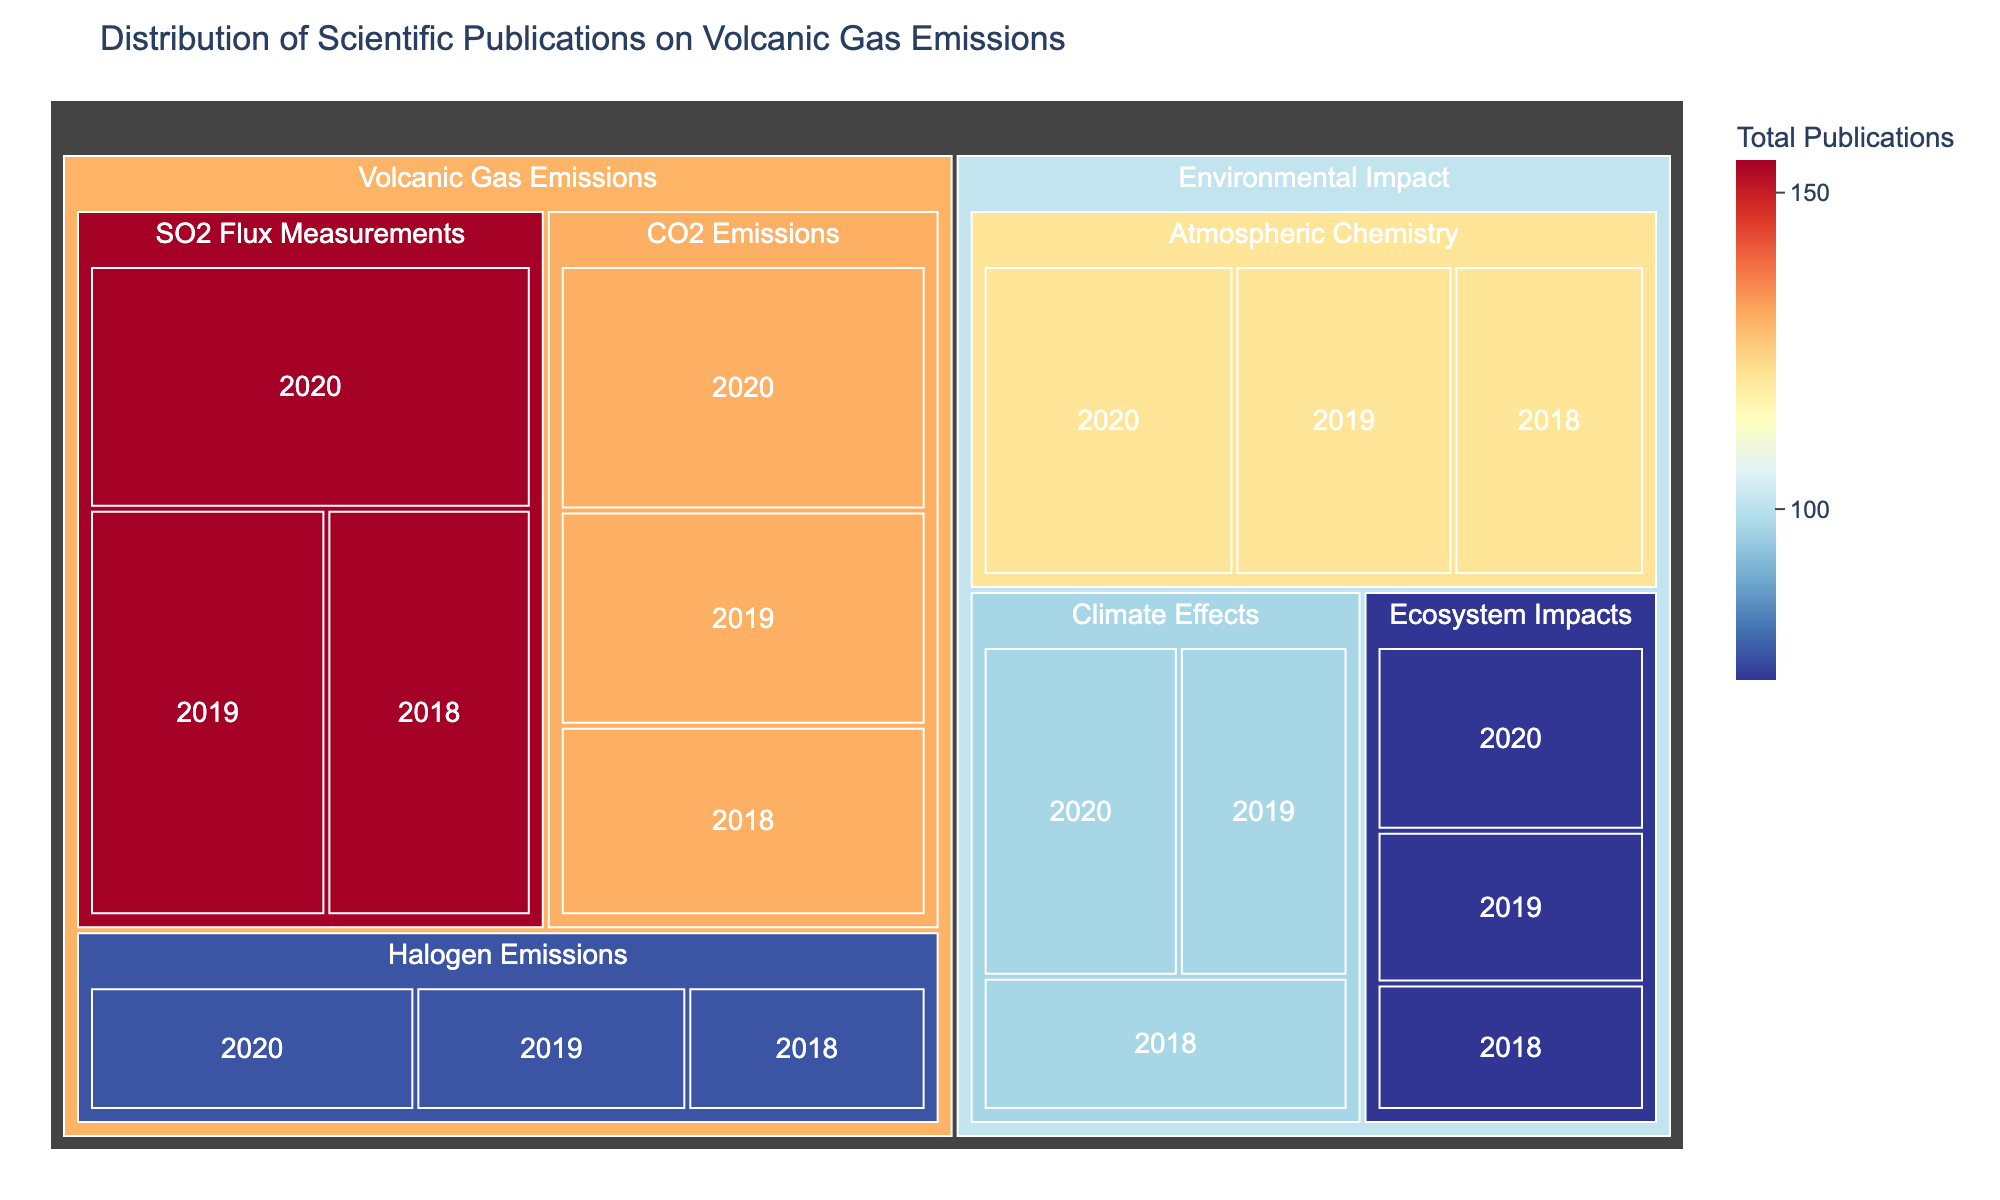Which Subtopic had the highest number of publications in 2020? To find the answer, look for the subtopic with the largest proportion within the year 2020. Visual elements like block sizes will help identify this. In this case, "SO2 Flux Measurements" had the largest proportion in 2020.
Answer: SO2 Flux Measurements How many total publications were there on Atmospheric Chemistry from 2018 to 2020? To calculate this, sum the yearly publications for Atmospheric Chemistry: 35 (2018) + 40 (2019) + 46 (2020). The total is 121.
Answer: 121 Which research subtopic under Environmental Impact had the fewest publications in 2018? Compare the block sizes for each subtopic under Environmental Impact for the year 2018. "Ecosystem Impacts" has the smallest block, indicating the fewest publications in 2018.
Answer: Ecosystem Impacts Which topic has a higher total number of publications, "Volcanic Gas Emissions" or "Environmental Impact"? Calculate total publications for each topic by summing their subtopics. For "Volcanic Gas Emissions": (45+52+58) + (38+43+49) + (22+25+30) = 362. For "Environmental Impact": (35+40+46) + (28+32+37) + (20+24+29) = 291. "Volcanic Gas Emissions" has more publications.
Answer: Volcanic Gas Emissions What is the trend of publications on Climate Effects from 2018 to 2020? Look for the direction of block size changes for "Climate Effects" from 2018 to 2020. Block sizes increase consistently, indicating an upward trend in publications.
Answer: Upward trend In which year were the most total publications made across all subtopics? To determine this, sum the publications for all subtopics each year and compare. 2018: 45+38+22+35+28+20 = 188, 2019: 52+43+25+40+32+24 = 216, 2020: 58+49+30+46+37+29 = 249. Hence, 2020 had the most publications.
Answer: 2020 Which subtopic had the smallest increase in publications from 2019 to 2020? Calculate the increase for each subtopic from 2019 to 2020: "SO2 Flux Measurements" (58-52 = 6), "CO2 Emissions" (49-43 = 6), "Halogen Emissions" (30-25 = 5), "Atmospheric Chemistry" (46-40 = 6), "Climate Effects" (37-32 = 5), "Ecosystem Impacts" (29-24 = 5). "Halogen Emissions," "Climate Effects," and "Ecosystem Impacts" each had the smallest increase (5).
Answer: Halogen Emissions, Climate Effects, Ecosystem Impacts What can be inferred about the research focus on SO2 Flux Measurements over the years? Observing the increasing block sizes from 2018 to 2020 for "SO2 Flux Measurements", it can be inferred that there was a growing interest and focus on this subtopic over the years.
Answer: Growing interest Which year shows the highest number of publications for CO2 Emissions? Compare the block sizes for "CO2 Emissions" for each year. The largest block appears in 2020, indicating the highest number of publications.
Answer: 2020 